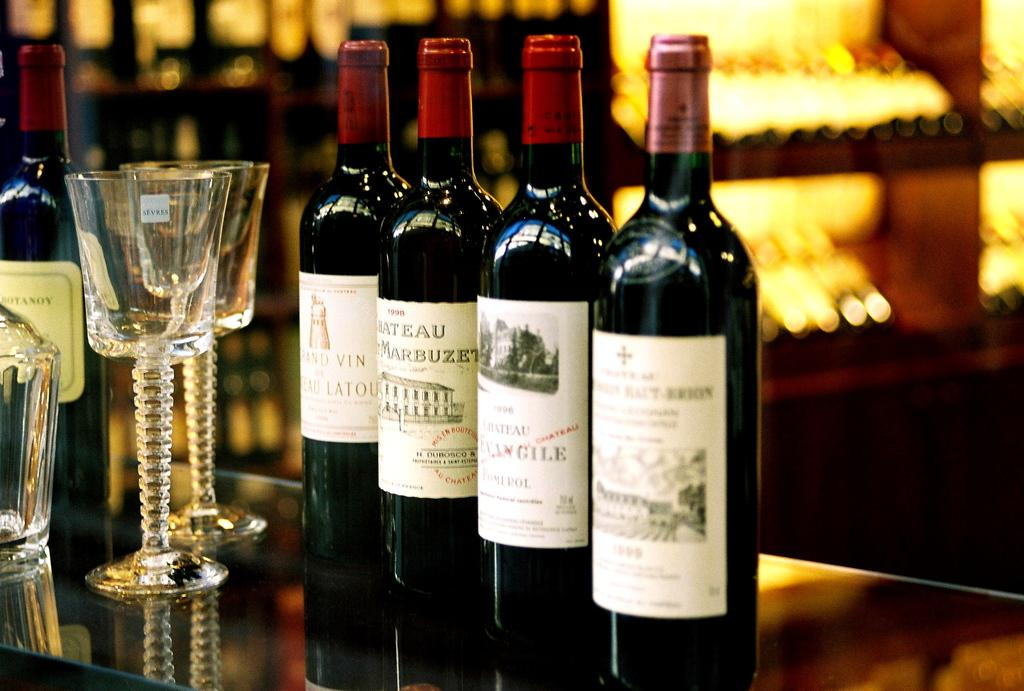<image>
Present a compact description of the photo's key features. the word Marbuzet is on the front of a bottle 